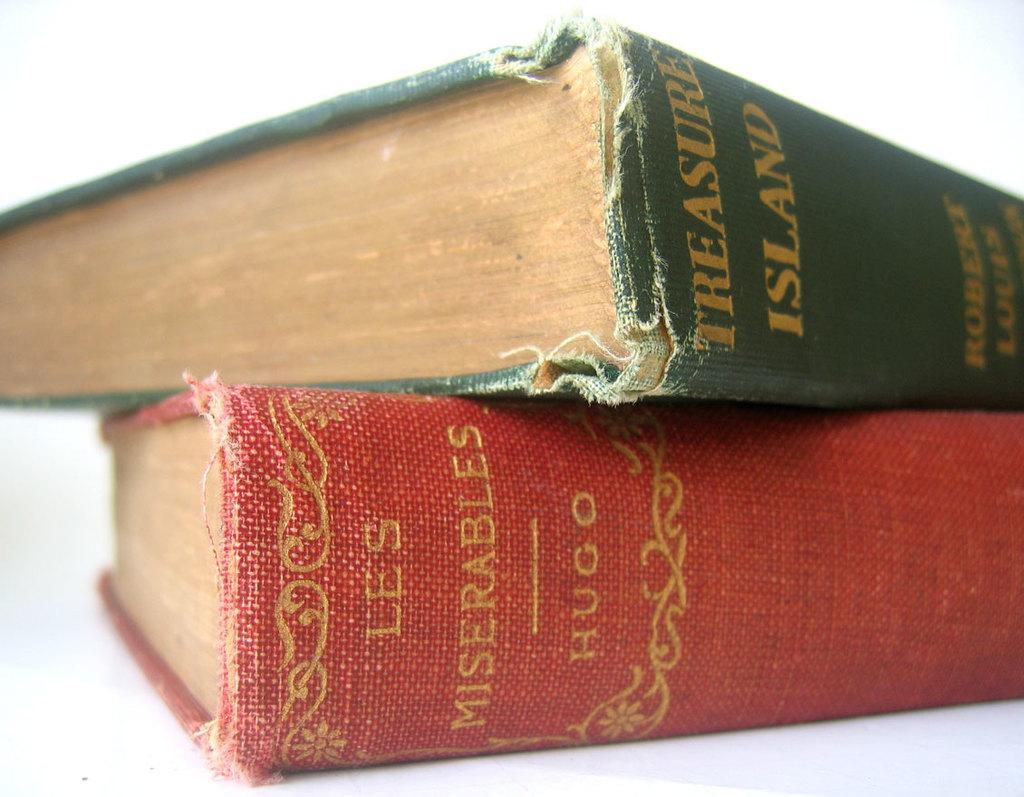<image>
Render a clear and concise summary of the photo. The book Treasure Island sitting on top of the book Les Miserables. 